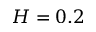<formula> <loc_0><loc_0><loc_500><loc_500>H = 0 . 2</formula> 